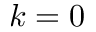<formula> <loc_0><loc_0><loc_500><loc_500>k = 0</formula> 